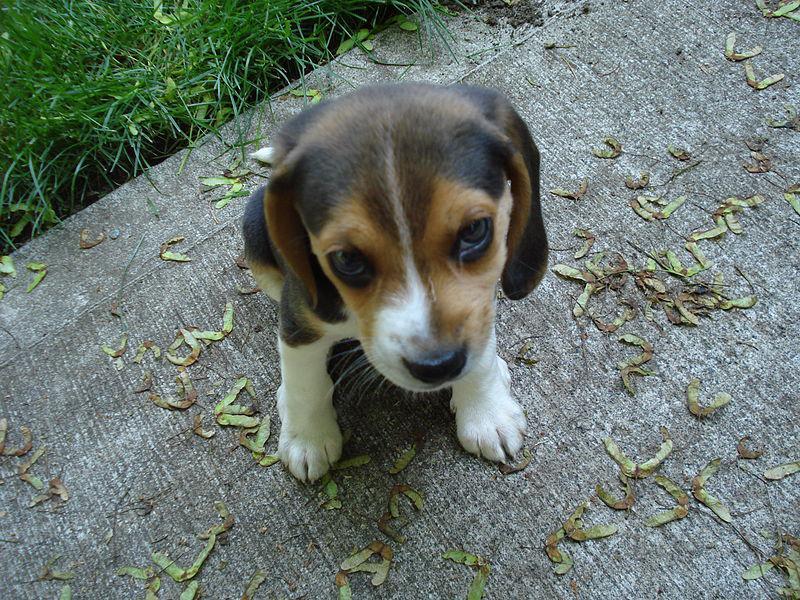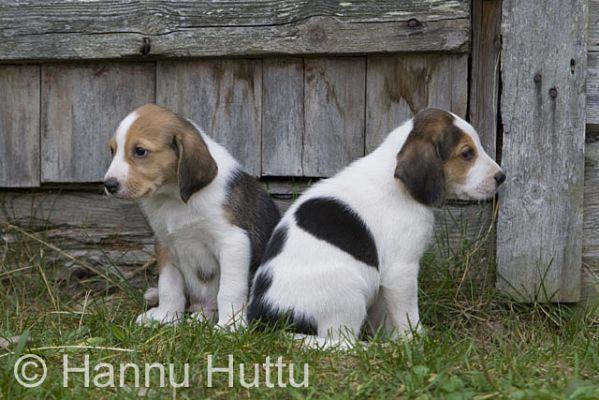The first image is the image on the left, the second image is the image on the right. Evaluate the accuracy of this statement regarding the images: "There are exactly two dogs in total.". Is it true? Answer yes or no. No. The first image is the image on the left, the second image is the image on the right. For the images displayed, is the sentence "Each image contains at least one beagle standing on all fours outdoors on the ground." factually correct? Answer yes or no. No. 